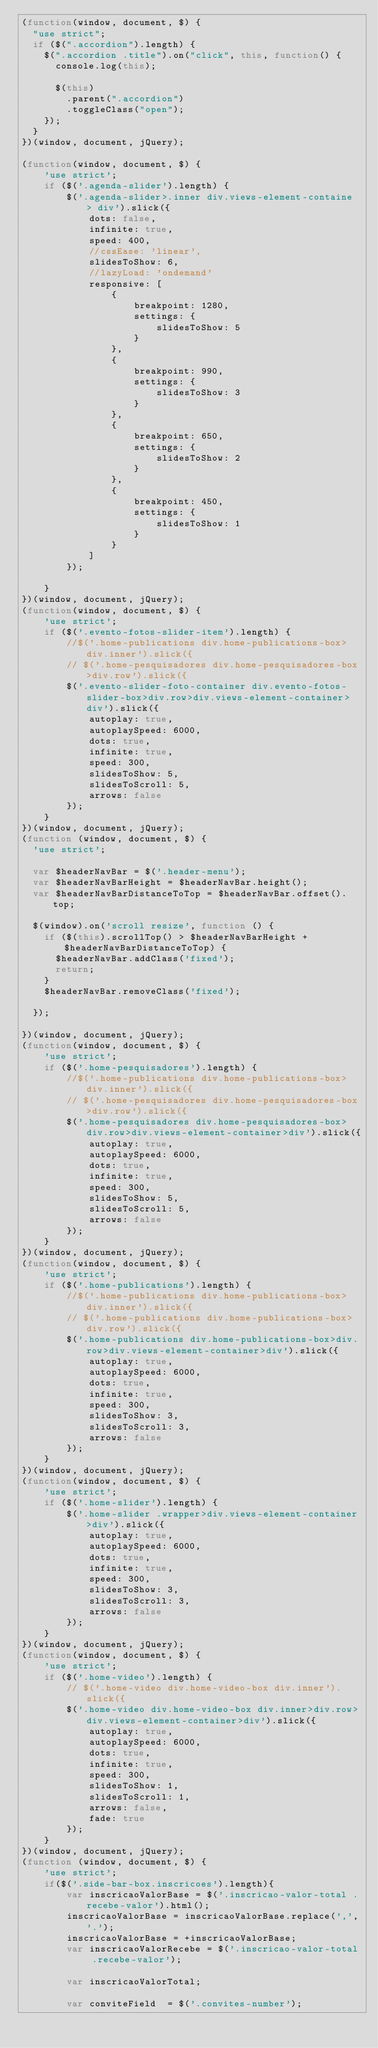<code> <loc_0><loc_0><loc_500><loc_500><_JavaScript_>(function(window, document, $) {
  "use strict";
  if ($(".accordion").length) {
    $(".accordion .title").on("click", this, function() {
      console.log(this);

      $(this)
        .parent(".accordion")
        .toggleClass("open");
    });
  }
})(window, document, jQuery);

(function(window, document, $) {
    'use strict';
    if ($('.agenda-slider').length) {
        $('.agenda-slider>.inner div.views-element-containe > div').slick({
            dots: false,
            infinite: true,
            speed: 400,
            //cssEase: 'linear',
            slidesToShow: 6,
            //lazyLoad: 'ondemand'
            responsive: [
                {
                    breakpoint: 1280,
                    settings: {
                        slidesToShow: 5
                    }
                },
                {
                    breakpoint: 990,
                    settings: {
                        slidesToShow: 3
                    }
                },
                {
                    breakpoint: 650,
                    settings: {
                        slidesToShow: 2
                    }
                },
                {
                    breakpoint: 450,
                    settings: {
                        slidesToShow: 1
                    }
                }
            ]
        });

    }
})(window, document, jQuery);
(function(window, document, $) {
    'use strict';
    if ($('.evento-fotos-slider-item').length) {
        //$('.home-publications div.home-publications-box>div.inner').slick({
        // $('.home-pesquisadores div.home-pesquisadores-box>div.row').slick({
        $('.evento-slider-foto-container div.evento-fotos-slider-box>div.row>div.views-element-container>div').slick({
            autoplay: true,
            autoplaySpeed: 6000,
            dots: true,
            infinite: true,
            speed: 300,
            slidesToShow: 5,
            slidesToScroll: 5,
            arrows: false
        });
    }
})(window, document, jQuery);
(function (window, document, $) {
  'use strict';

  var $headerNavBar = $('.header-menu');
  var $headerNavBarHeight = $headerNavBar.height();
  var $headerNavBarDistanceToTop = $headerNavBar.offset().top;

  $(window).on('scroll resize', function () {
    if ($(this).scrollTop() > $headerNavBarHeight + $headerNavBarDistanceToTop) {
      $headerNavBar.addClass('fixed');
      return;
    }
    $headerNavBar.removeClass('fixed');

  });

})(window, document, jQuery);
(function(window, document, $) {
    'use strict';
    if ($('.home-pesquisadores').length) {
        //$('.home-publications div.home-publications-box>div.inner').slick({
        // $('.home-pesquisadores div.home-pesquisadores-box>div.row').slick({
        $('.home-pesquisadores div.home-pesquisadores-box>div.row>div.views-element-container>div').slick({
            autoplay: true,
            autoplaySpeed: 6000,
            dots: true,
            infinite: true,
            speed: 300,
            slidesToShow: 5,
            slidesToScroll: 5,
            arrows: false
        });
    }
})(window, document, jQuery);
(function(window, document, $) {
    'use strict';
    if ($('.home-publications').length) {
        //$('.home-publications div.home-publications-box>div.inner').slick({
        // $('.home-publications div.home-publications-box>div.row').slick({
        $('.home-publications div.home-publications-box>div.row>div.views-element-container>div').slick({
            autoplay: true,
            autoplaySpeed: 6000,
            dots: true,
            infinite: true,
            speed: 300,
            slidesToShow: 3,
            slidesToScroll: 3,
            arrows: false
        });
    }
})(window, document, jQuery);
(function(window, document, $) {
    'use strict';
    if ($('.home-slider').length) {
        $('.home-slider .wrapper>div.views-element-container>div').slick({
            autoplay: true,
            autoplaySpeed: 6000,
            dots: true,
            infinite: true,
            speed: 300,
            slidesToShow: 3,
            slidesToScroll: 3,
            arrows: false
        });
    }
})(window, document, jQuery);
(function(window, document, $) {
    'use strict';
    if ($('.home-video').length) {
        // $('.home-video div.home-video-box div.inner').slick({
        $('.home-video div.home-video-box div.inner>div.row>div.views-element-container>div').slick({
            autoplay: true,
            autoplaySpeed: 6000,
            dots: true,
            infinite: true,
            speed: 300,
            slidesToShow: 1,
            slidesToScroll: 1,
            arrows: false,
            fade: true
        });
    }
})(window, document, jQuery);
(function (window, document, $) {
    'use strict';
    if($('.side-bar-box.inscricoes').length){
        var inscricaoValorBase = $('.inscricao-valor-total .recebe-valor').html();
        inscricaoValorBase = inscricaoValorBase.replace(',','.');
        inscricaoValorBase = +inscricaoValorBase;
        var inscricaoValorRecebe = $('.inscricao-valor-total .recebe-valor');

        var inscricaoValorTotal;

        var conviteField  = $('.convites-number');</code> 